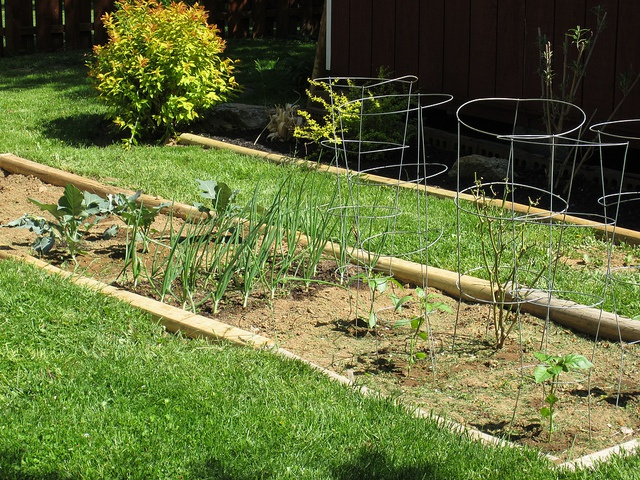Describe the objects in this image and their specific colors. I can see a broccoli in black, gray, and darkgreen tones in this image. 